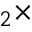Convert formula to latex. <formula><loc_0><loc_0><loc_500><loc_500>_ { 2 } \times</formula> 